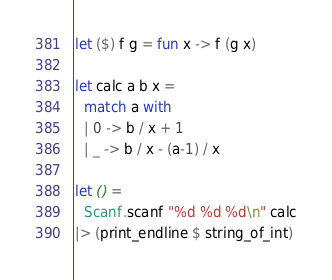Convert code to text. <code><loc_0><loc_0><loc_500><loc_500><_OCaml_>let ($) f g = fun x -> f (g x)

let calc a b x =
  match a with
  | 0 -> b / x + 1
  | _ -> b / x - (a-1) / x

let () =
  Scanf.scanf "%d %d %d\n" calc
|> (print_endline $ string_of_int)
</code> 